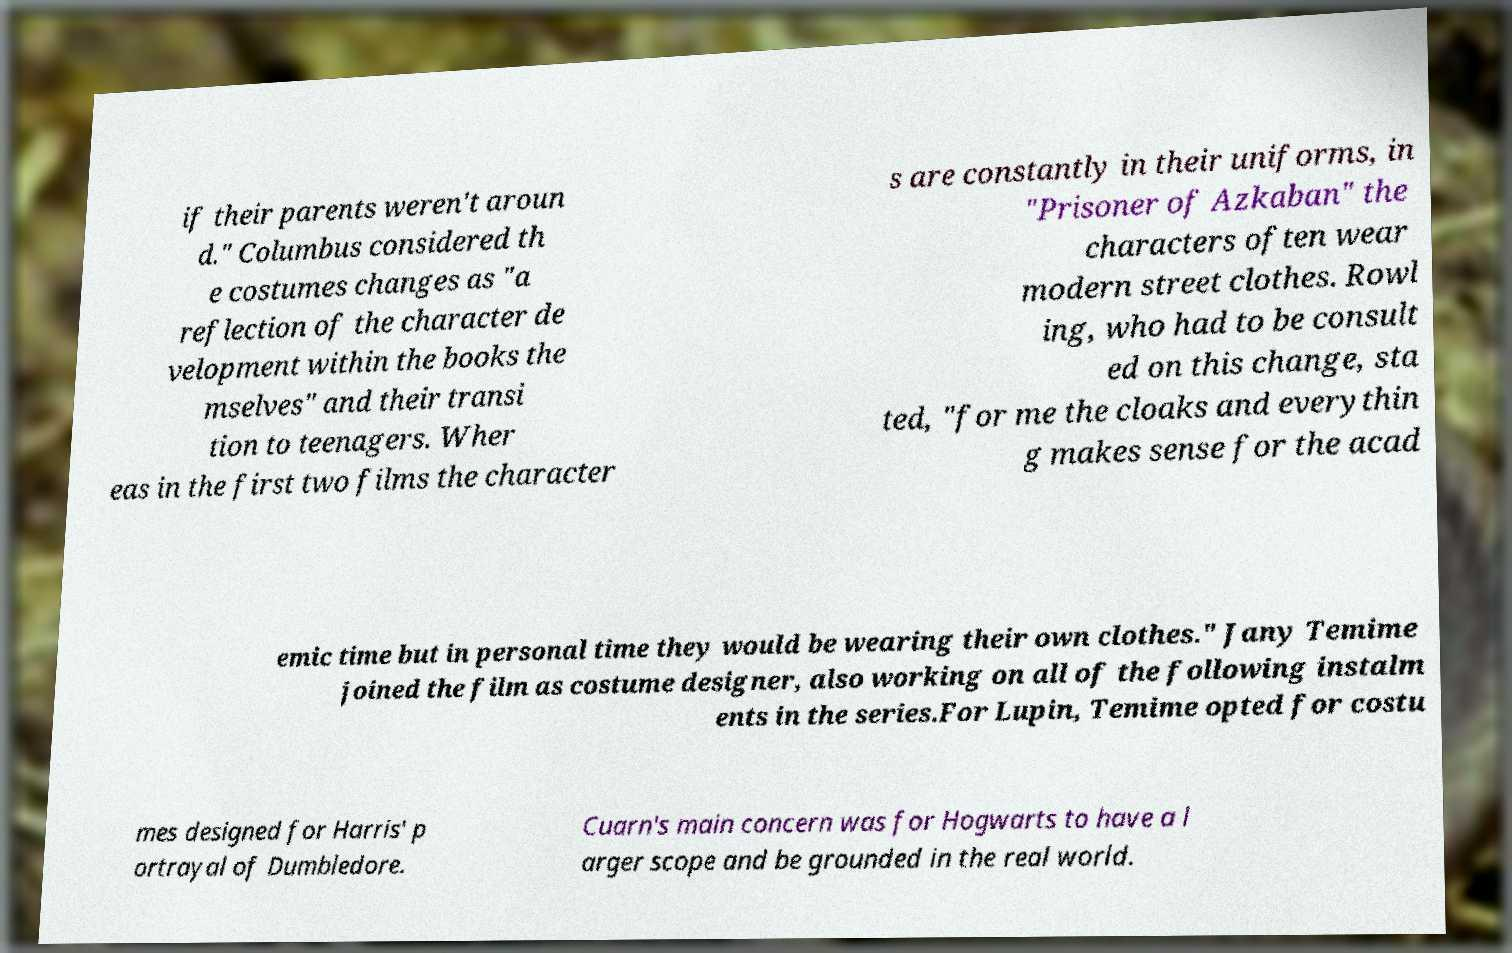Can you read and provide the text displayed in the image?This photo seems to have some interesting text. Can you extract and type it out for me? if their parents weren't aroun d." Columbus considered th e costumes changes as "a reflection of the character de velopment within the books the mselves" and their transi tion to teenagers. Wher eas in the first two films the character s are constantly in their uniforms, in "Prisoner of Azkaban" the characters often wear modern street clothes. Rowl ing, who had to be consult ed on this change, sta ted, "for me the cloaks and everythin g makes sense for the acad emic time but in personal time they would be wearing their own clothes." Jany Temime joined the film as costume designer, also working on all of the following instalm ents in the series.For Lupin, Temime opted for costu mes designed for Harris' p ortrayal of Dumbledore. Cuarn's main concern was for Hogwarts to have a l arger scope and be grounded in the real world. 